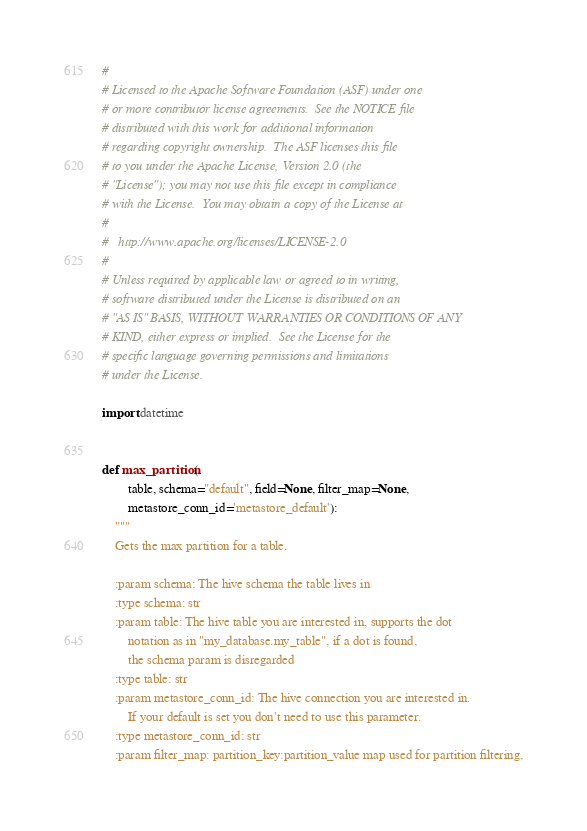<code> <loc_0><loc_0><loc_500><loc_500><_Python_>#
# Licensed to the Apache Software Foundation (ASF) under one
# or more contributor license agreements.  See the NOTICE file
# distributed with this work for additional information
# regarding copyright ownership.  The ASF licenses this file
# to you under the Apache License, Version 2.0 (the
# "License"); you may not use this file except in compliance
# with the License.  You may obtain a copy of the License at
#
#   http://www.apache.org/licenses/LICENSE-2.0
#
# Unless required by applicable law or agreed to in writing,
# software distributed under the License is distributed on an
# "AS IS" BASIS, WITHOUT WARRANTIES OR CONDITIONS OF ANY
# KIND, either express or implied.  See the License for the
# specific language governing permissions and limitations
# under the License.

import datetime


def max_partition(
        table, schema="default", field=None, filter_map=None,
        metastore_conn_id='metastore_default'):
    """
    Gets the max partition for a table.

    :param schema: The hive schema the table lives in
    :type schema: str
    :param table: The hive table you are interested in, supports the dot
        notation as in "my_database.my_table", if a dot is found,
        the schema param is disregarded
    :type table: str
    :param metastore_conn_id: The hive connection you are interested in.
        If your default is set you don't need to use this parameter.
    :type metastore_conn_id: str
    :param filter_map: partition_key:partition_value map used for partition filtering,</code> 